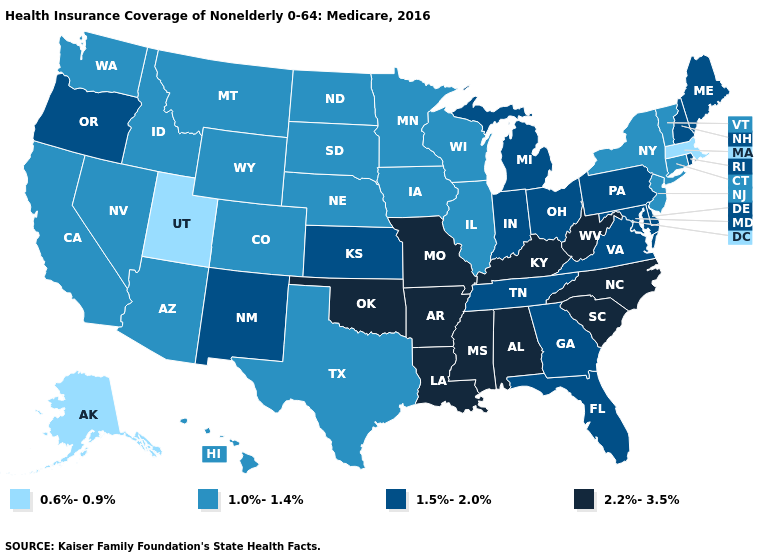Name the states that have a value in the range 1.5%-2.0%?
Answer briefly. Delaware, Florida, Georgia, Indiana, Kansas, Maine, Maryland, Michigan, New Hampshire, New Mexico, Ohio, Oregon, Pennsylvania, Rhode Island, Tennessee, Virginia. Does Vermont have the highest value in the Northeast?
Concise answer only. No. Among the states that border Massachusetts , which have the lowest value?
Keep it brief. Connecticut, New York, Vermont. What is the value of Wyoming?
Answer briefly. 1.0%-1.4%. Does North Dakota have the lowest value in the USA?
Write a very short answer. No. Does Iowa have the lowest value in the USA?
Concise answer only. No. Among the states that border Arizona , which have the lowest value?
Give a very brief answer. Utah. What is the highest value in the West ?
Give a very brief answer. 1.5%-2.0%. What is the lowest value in states that border Delaware?
Answer briefly. 1.0%-1.4%. How many symbols are there in the legend?
Concise answer only. 4. Does Oklahoma have the highest value in the South?
Answer briefly. Yes. Name the states that have a value in the range 2.2%-3.5%?
Short answer required. Alabama, Arkansas, Kentucky, Louisiana, Mississippi, Missouri, North Carolina, Oklahoma, South Carolina, West Virginia. Among the states that border Kentucky , which have the highest value?
Be succinct. Missouri, West Virginia. Name the states that have a value in the range 1.0%-1.4%?
Give a very brief answer. Arizona, California, Colorado, Connecticut, Hawaii, Idaho, Illinois, Iowa, Minnesota, Montana, Nebraska, Nevada, New Jersey, New York, North Dakota, South Dakota, Texas, Vermont, Washington, Wisconsin, Wyoming. 